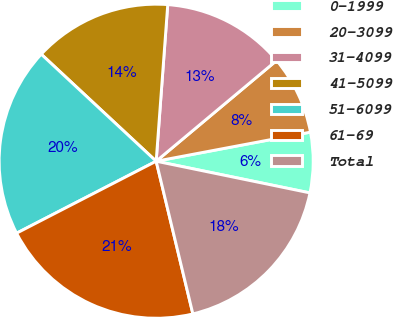Convert chart to OTSL. <chart><loc_0><loc_0><loc_500><loc_500><pie_chart><fcel>0-1999<fcel>20-3099<fcel>31-4099<fcel>41-5099<fcel>51-6099<fcel>61-69<fcel>Total<nl><fcel>6.2%<fcel>8.12%<fcel>12.74%<fcel>14.24%<fcel>19.51%<fcel>21.18%<fcel>18.01%<nl></chart> 